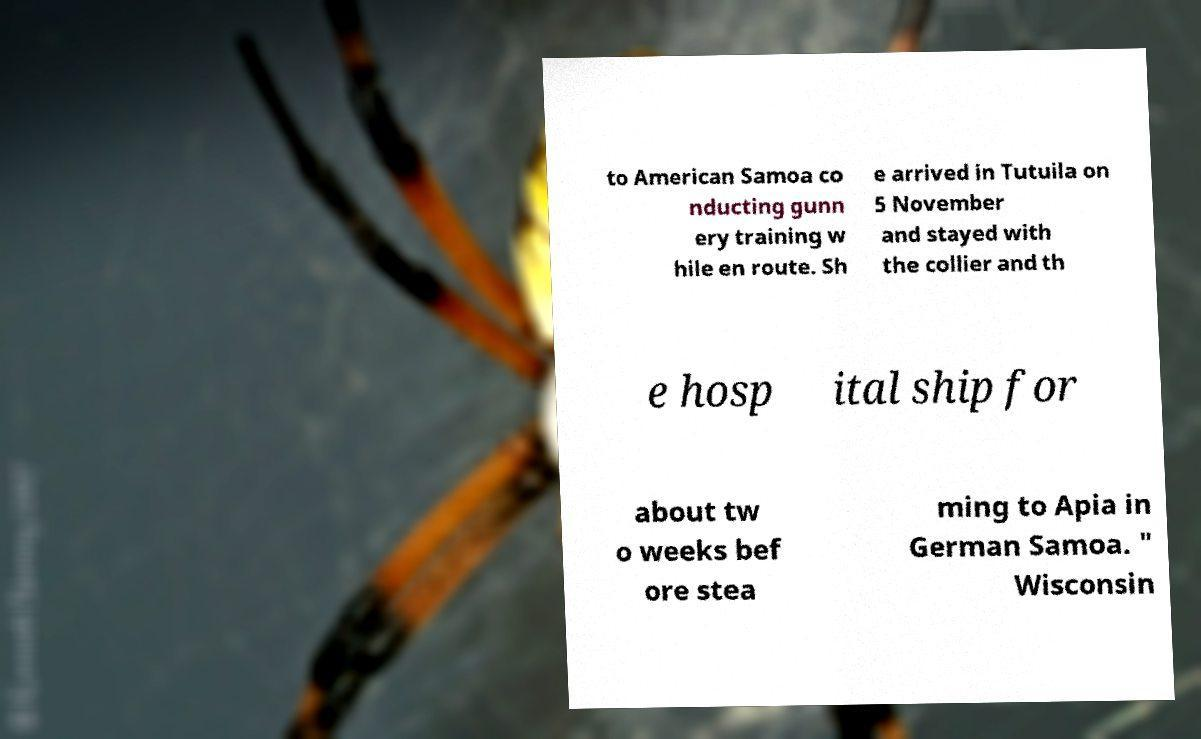Could you assist in decoding the text presented in this image and type it out clearly? to American Samoa co nducting gunn ery training w hile en route. Sh e arrived in Tutuila on 5 November and stayed with the collier and th e hosp ital ship for about tw o weeks bef ore stea ming to Apia in German Samoa. " Wisconsin 